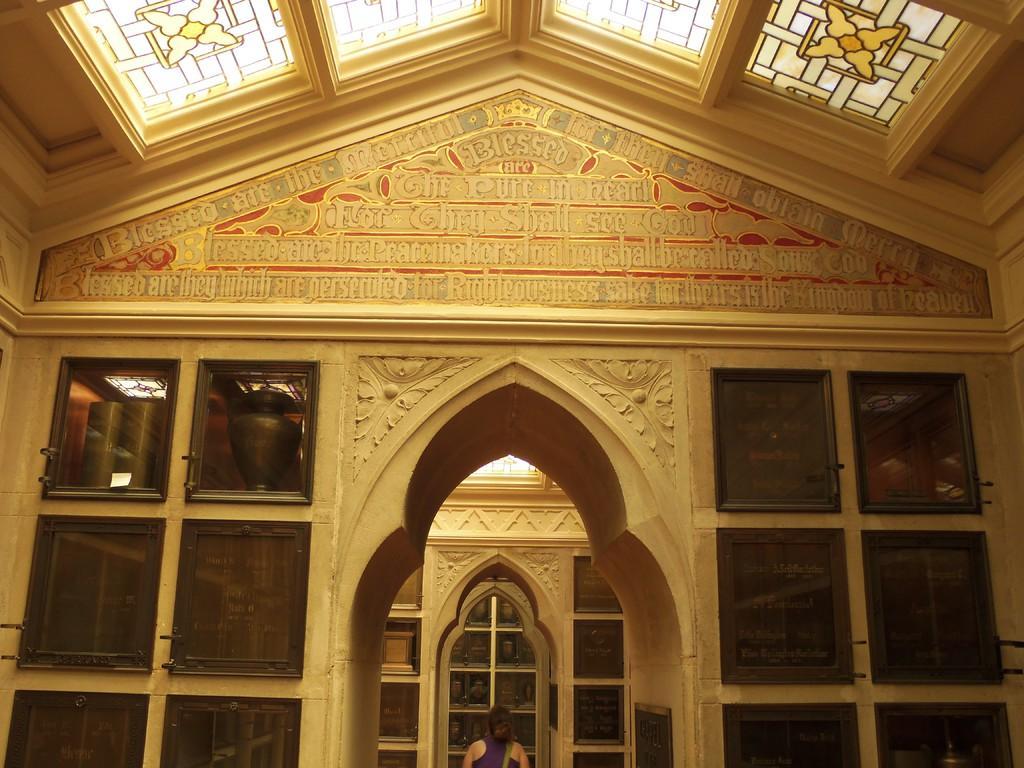Please provide a concise description of this image. In this image we can see a wall on which we can see some text and the glass windows. Here we can see a person standing. Here we can see the ceiling made of glass. 